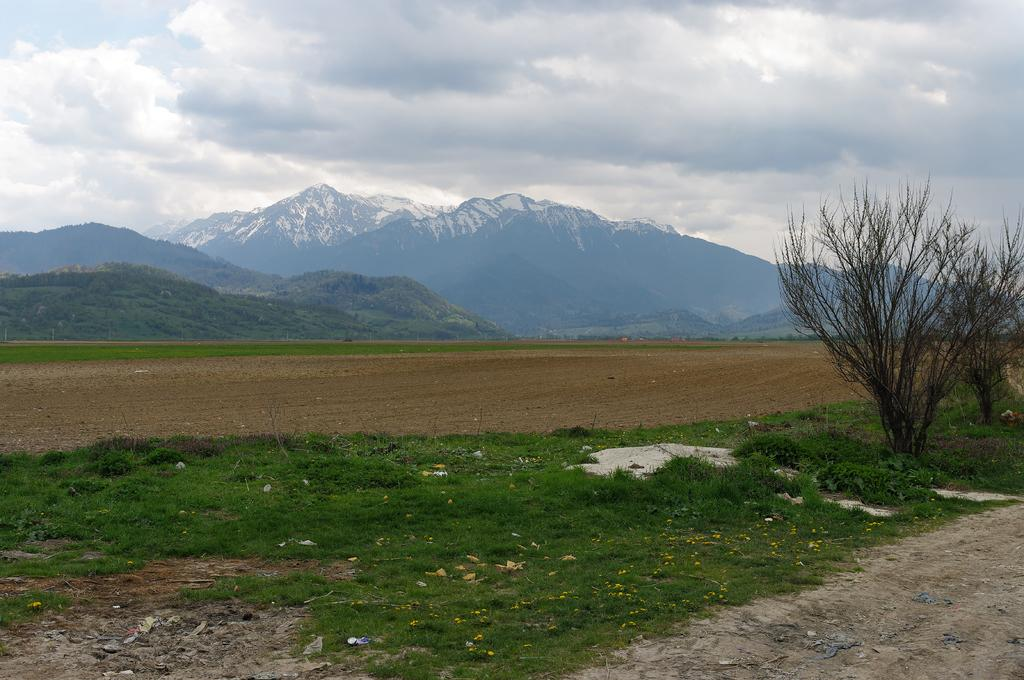What type of vegetation is at the bottom of the image? There is grass at the bottom of the image. What can be seen on the right side of the image? There are plants on the right side of the image. What natural feature is visible in the background of the image? There are mountains in the background of the image. What is visible at the top of the image? The sky is visible at the top of the image. How many people are sleeping in the image? There are no people visible in the image, let alone sleeping. What type of example can be seen in the image? There is no example present in the image; it features grass, plants, mountains, and the sky. 